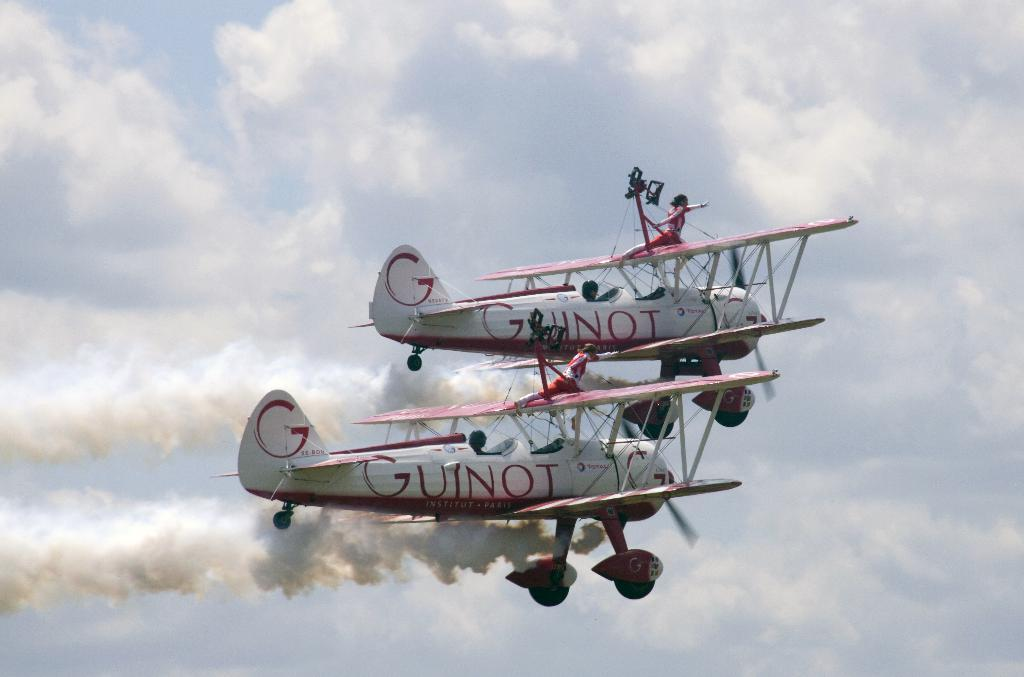<image>
Share a concise interpretation of the image provided. acrobats on planes in the sky reading Guinot 